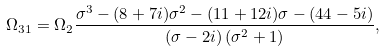<formula> <loc_0><loc_0><loc_500><loc_500>\Omega _ { 3 1 } = \Omega _ { 2 } \frac { \sigma ^ { 3 } - ( 8 + 7 i ) \sigma ^ { 2 } - ( 1 1 + 1 2 i ) \sigma - ( 4 4 - 5 i ) } { \left ( \sigma - 2 i \right ) \left ( \sigma ^ { 2 } + 1 \right ) } ,</formula> 